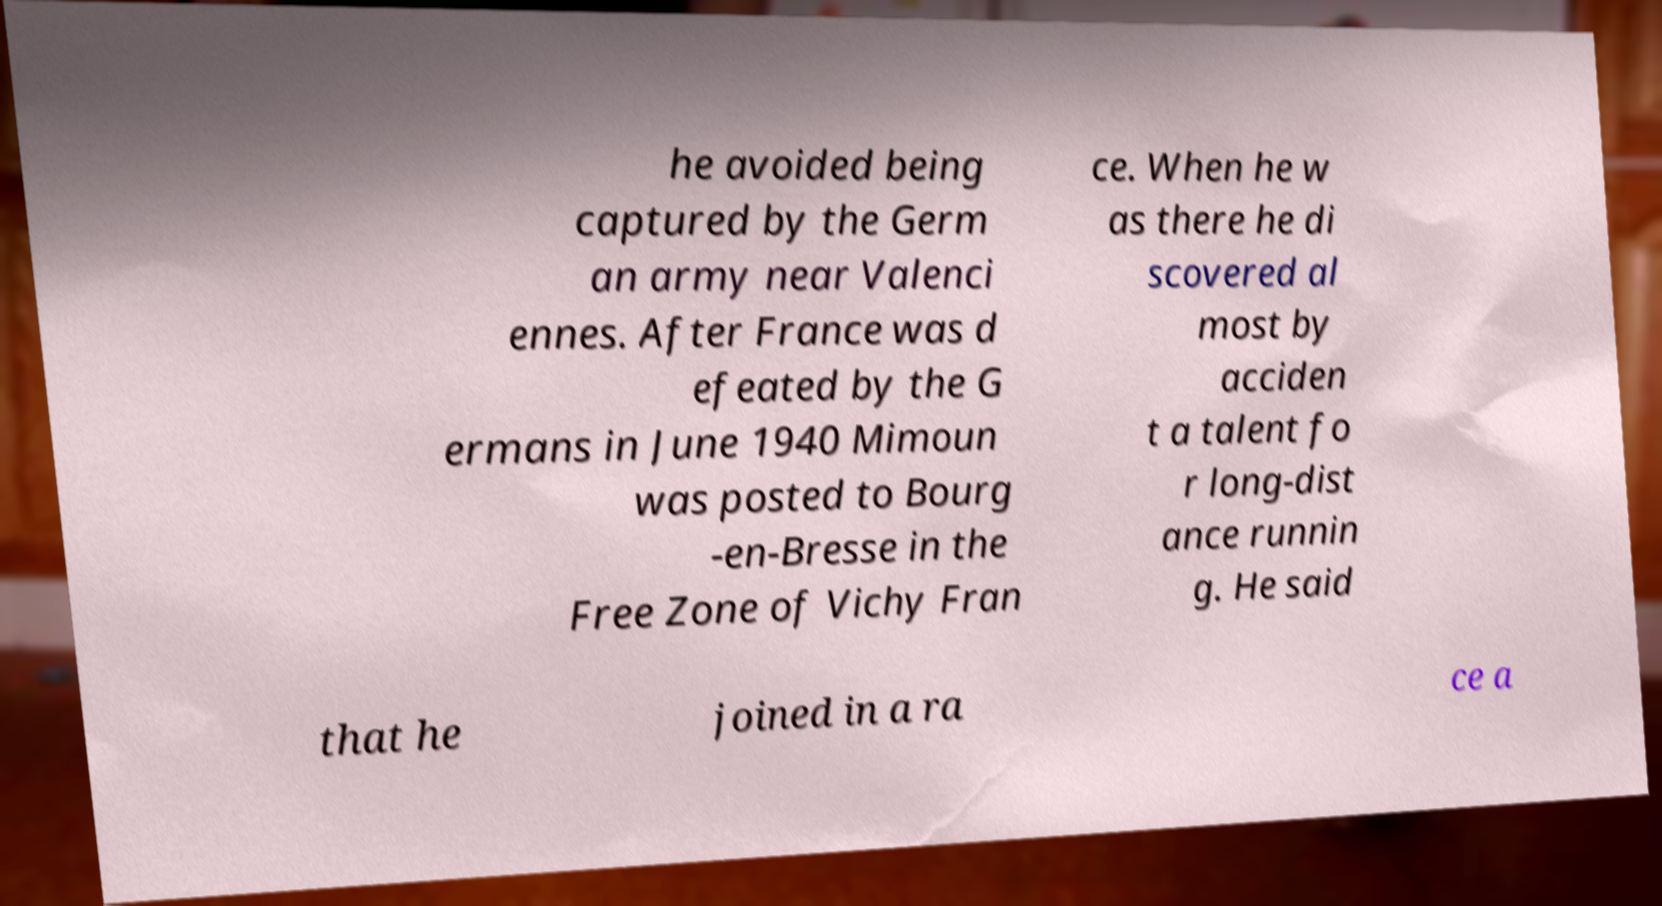What messages or text are displayed in this image? I need them in a readable, typed format. he avoided being captured by the Germ an army near Valenci ennes. After France was d efeated by the G ermans in June 1940 Mimoun was posted to Bourg -en-Bresse in the Free Zone of Vichy Fran ce. When he w as there he di scovered al most by acciden t a talent fo r long-dist ance runnin g. He said that he joined in a ra ce a 